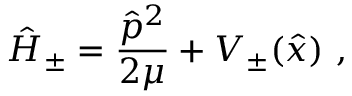<formula> <loc_0><loc_0><loc_500><loc_500>\hat { H } _ { \pm } = \frac { \hat { p } ^ { 2 } } { 2 \mu } + V _ { \pm } ( \hat { x } ) \ ,</formula> 